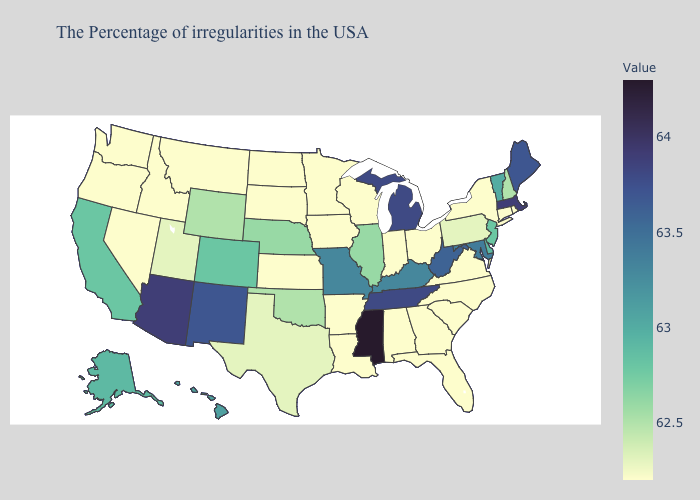Does Oklahoma have the lowest value in the South?
Write a very short answer. No. Among the states that border Louisiana , does Texas have the lowest value?
Concise answer only. No. Does Maine have the lowest value in the Northeast?
Be succinct. No. Among the states that border Utah , which have the lowest value?
Give a very brief answer. Idaho, Nevada. Which states hav the highest value in the Northeast?
Be succinct. Massachusetts. Does North Dakota have a lower value than Illinois?
Give a very brief answer. Yes. 